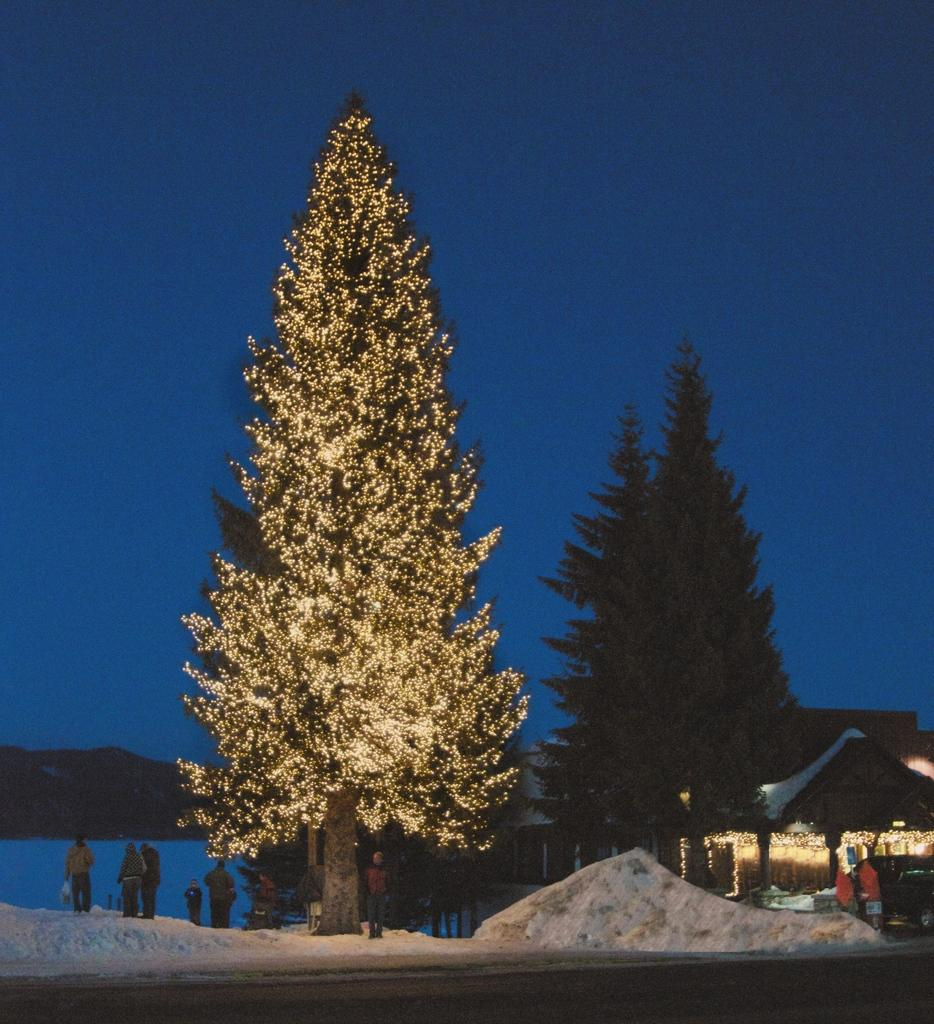What type of structure is visible in the picture? There is a house in the picture. What is the weather like in the picture? There is snow in the picture, indicating a cold or wintery setting. Can you describe the people in the picture? There is a group of people standing in the picture. What type of vegetation is present in the picture? There are trees in the picture. Can you describe any decorations in the picture? There is a tree decorated with lights in the picture. What is visible in the background of the picture? The sky is visible in the background of the picture. What type of word is being used to describe the trousers in the picture? There are no trousers present in the picture, so it is not possible to describe any words used to describe them. What type of quilt is being used to cover the people in the picture? There are no quilts present in the picture, and the people are not covered by any blankets or coverings. 